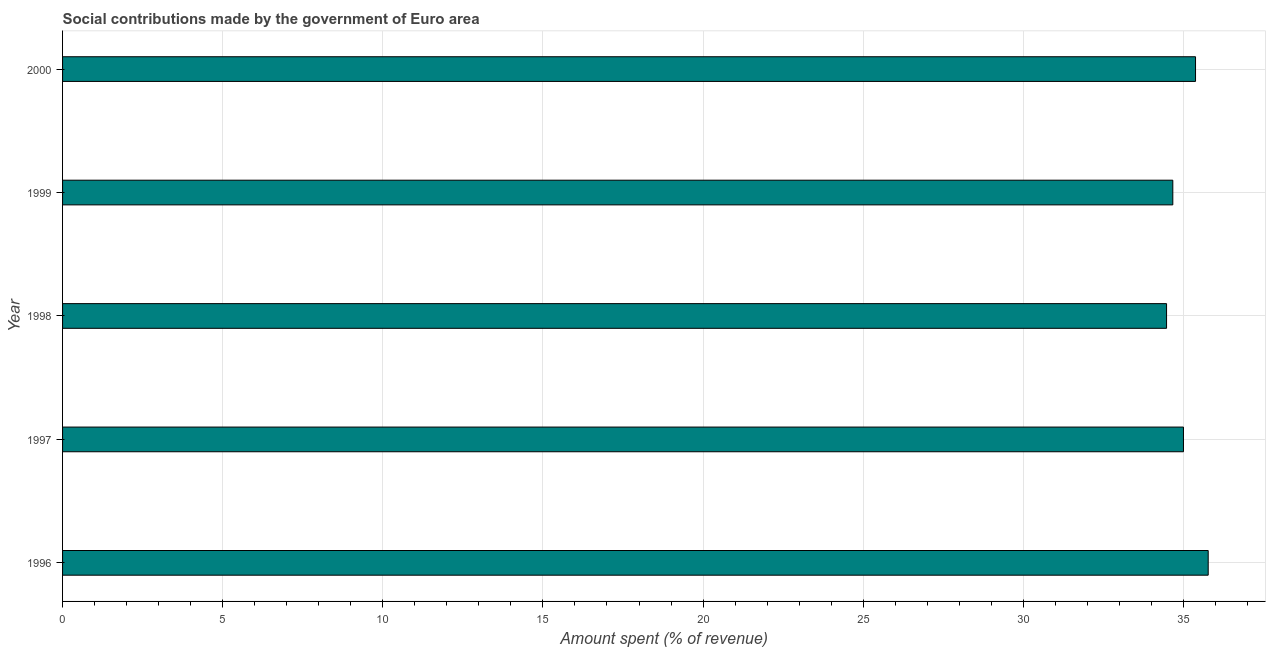What is the title of the graph?
Your answer should be compact. Social contributions made by the government of Euro area. What is the label or title of the X-axis?
Give a very brief answer. Amount spent (% of revenue). What is the amount spent in making social contributions in 1996?
Offer a terse response. 35.77. Across all years, what is the maximum amount spent in making social contributions?
Your response must be concise. 35.77. Across all years, what is the minimum amount spent in making social contributions?
Keep it short and to the point. 34.47. In which year was the amount spent in making social contributions maximum?
Offer a very short reply. 1996. What is the sum of the amount spent in making social contributions?
Make the answer very short. 175.3. What is the difference between the amount spent in making social contributions in 1996 and 1999?
Your response must be concise. 1.1. What is the average amount spent in making social contributions per year?
Ensure brevity in your answer.  35.06. What is the median amount spent in making social contributions?
Ensure brevity in your answer.  35. In how many years, is the amount spent in making social contributions greater than 18 %?
Your response must be concise. 5. What is the ratio of the amount spent in making social contributions in 1999 to that in 2000?
Provide a short and direct response. 0.98. What is the difference between the highest and the second highest amount spent in making social contributions?
Keep it short and to the point. 0.4. Are all the bars in the graph horizontal?
Provide a succinct answer. Yes. How many years are there in the graph?
Offer a terse response. 5. Are the values on the major ticks of X-axis written in scientific E-notation?
Provide a short and direct response. No. What is the Amount spent (% of revenue) in 1996?
Give a very brief answer. 35.77. What is the Amount spent (% of revenue) of 1997?
Ensure brevity in your answer.  35. What is the Amount spent (% of revenue) of 1998?
Provide a succinct answer. 34.47. What is the Amount spent (% of revenue) of 1999?
Give a very brief answer. 34.67. What is the Amount spent (% of revenue) of 2000?
Provide a short and direct response. 35.38. What is the difference between the Amount spent (% of revenue) in 1996 and 1997?
Provide a succinct answer. 0.77. What is the difference between the Amount spent (% of revenue) in 1996 and 1998?
Provide a short and direct response. 1.3. What is the difference between the Amount spent (% of revenue) in 1996 and 1999?
Keep it short and to the point. 1.11. What is the difference between the Amount spent (% of revenue) in 1996 and 2000?
Ensure brevity in your answer.  0.4. What is the difference between the Amount spent (% of revenue) in 1997 and 1998?
Provide a short and direct response. 0.53. What is the difference between the Amount spent (% of revenue) in 1997 and 1999?
Your answer should be very brief. 0.33. What is the difference between the Amount spent (% of revenue) in 1997 and 2000?
Provide a succinct answer. -0.38. What is the difference between the Amount spent (% of revenue) in 1998 and 1999?
Offer a terse response. -0.2. What is the difference between the Amount spent (% of revenue) in 1998 and 2000?
Your answer should be very brief. -0.9. What is the difference between the Amount spent (% of revenue) in 1999 and 2000?
Ensure brevity in your answer.  -0.71. What is the ratio of the Amount spent (% of revenue) in 1996 to that in 1998?
Keep it short and to the point. 1.04. What is the ratio of the Amount spent (% of revenue) in 1996 to that in 1999?
Offer a terse response. 1.03. What is the ratio of the Amount spent (% of revenue) in 1997 to that in 1998?
Give a very brief answer. 1.01. What is the ratio of the Amount spent (% of revenue) in 1997 to that in 1999?
Offer a terse response. 1.01. What is the ratio of the Amount spent (% of revenue) in 1997 to that in 2000?
Offer a terse response. 0.99. What is the ratio of the Amount spent (% of revenue) in 1998 to that in 1999?
Provide a succinct answer. 0.99. What is the ratio of the Amount spent (% of revenue) in 1998 to that in 2000?
Your response must be concise. 0.97. What is the ratio of the Amount spent (% of revenue) in 1999 to that in 2000?
Ensure brevity in your answer.  0.98. 